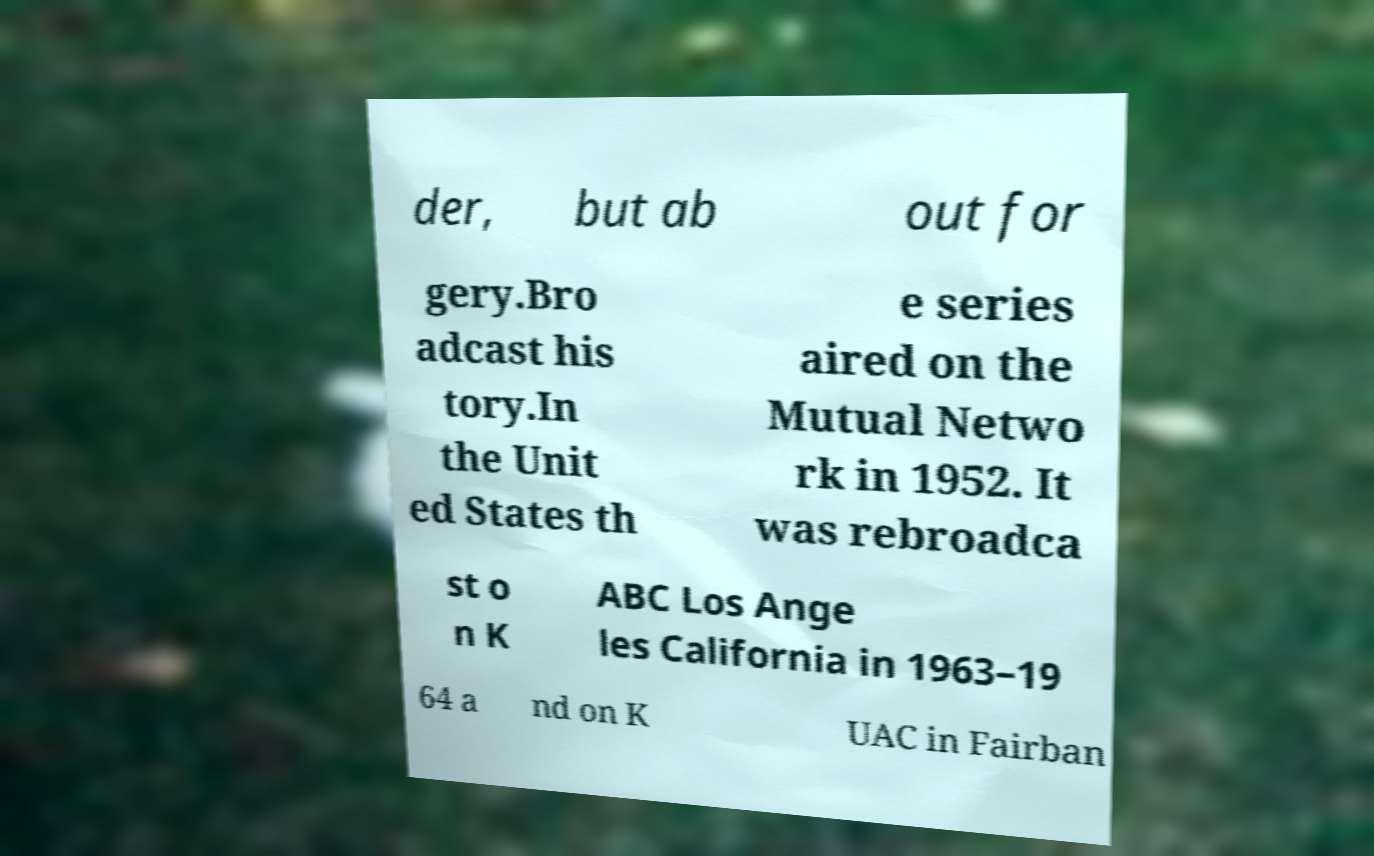Can you accurately transcribe the text from the provided image for me? der, but ab out for gery.Bro adcast his tory.In the Unit ed States th e series aired on the Mutual Netwo rk in 1952. It was rebroadca st o n K ABC Los Ange les California in 1963–19 64 a nd on K UAC in Fairban 